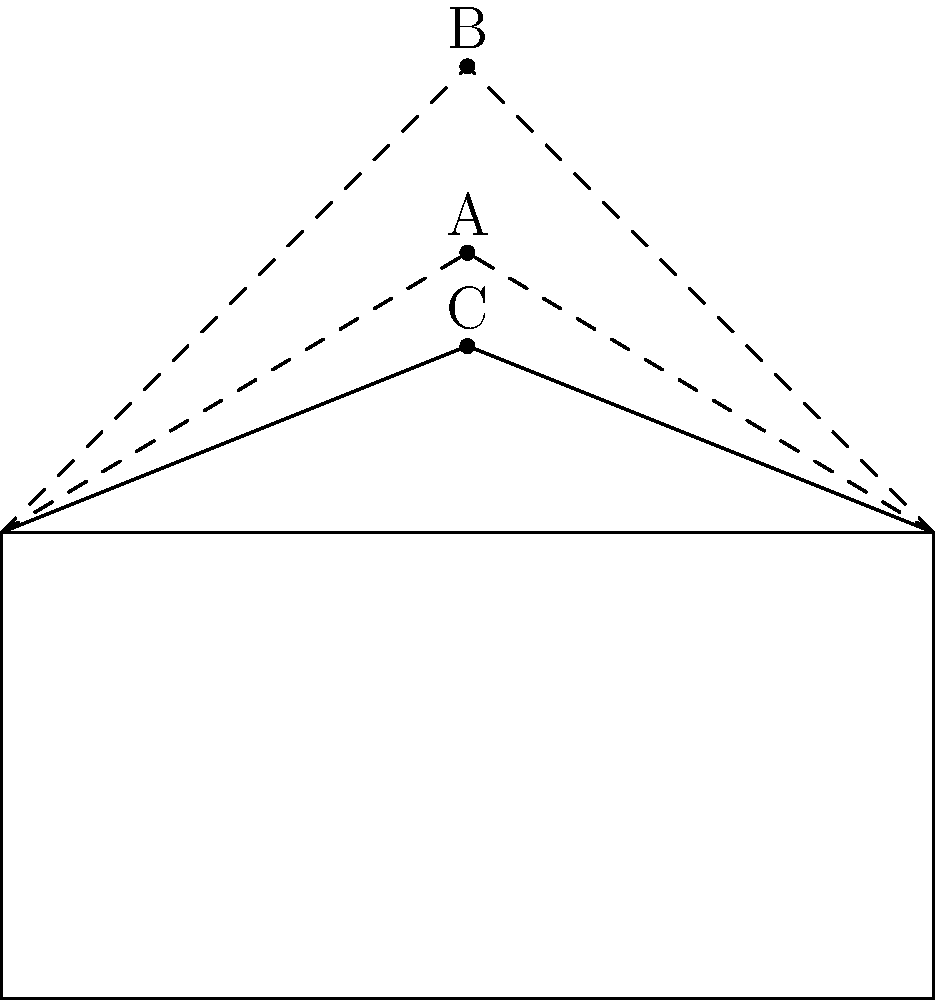In a restoration project of a 17th-century Tudor-style manor, you need to determine the correct roof angle. Based on your research of Tudor architecture, which of the labeled angles (A, B, or C) most accurately represents the typical roof pitch of this period? To determine the correct roof angle for a 17th-century Tudor-style manor, we need to consider the following steps:

1. Tudor architecture, which was prevalent in England from the late 15th to early 17th century, is known for its distinctive steep roof pitches.

2. The typical roof pitch for Tudor-style buildings ranges from 45° to 60° from the horizontal.

3. In the diagram:
   - Angle A represents a pitch of approximately 45°
   - Angle B represents a pitch of approximately 60°
   - Angle C represents a pitch of approximately 30°

4. Among these options, Angle B (60°) falls within the typical range for Tudor architecture and represents the steepest pitch.

5. The steep pitch in Tudor architecture served practical purposes:
   - It allowed for efficient water and snow runoff
   - It created additional living space in the attic
   - It was a defining aesthetic feature of the style

6. While Angle A (45°) is also within the acceptable range, the steeper Angle B is more characteristic of the elaborate and grand Tudor manors of the 17th century.

Therefore, Angle B most accurately represents the typical roof pitch of a 17th-century Tudor-style manor.
Answer: B 